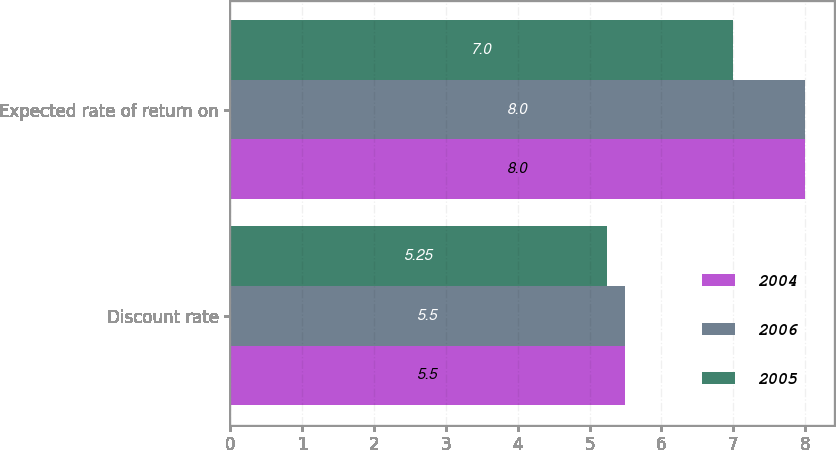Convert chart. <chart><loc_0><loc_0><loc_500><loc_500><stacked_bar_chart><ecel><fcel>Discount rate<fcel>Expected rate of return on<nl><fcel>2004<fcel>5.5<fcel>8<nl><fcel>2006<fcel>5.5<fcel>8<nl><fcel>2005<fcel>5.25<fcel>7<nl></chart> 